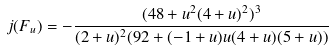<formula> <loc_0><loc_0><loc_500><loc_500>j ( F _ { u } ) = - \frac { ( 4 8 + u ^ { 2 } ( 4 + u ) ^ { 2 } ) ^ { 3 } } { ( 2 + u ) ^ { 2 } ( 9 2 + ( - 1 + u ) u ( 4 + u ) ( 5 + u ) ) }</formula> 